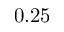<formula> <loc_0><loc_0><loc_500><loc_500>0 . 2 5</formula> 